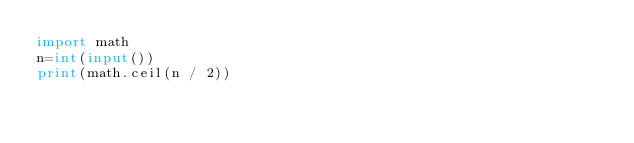Convert code to text. <code><loc_0><loc_0><loc_500><loc_500><_Python_>import math
n=int(input())
print(math.ceil(n / 2))</code> 